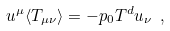Convert formula to latex. <formula><loc_0><loc_0><loc_500><loc_500>u ^ { \mu } \langle T _ { \mu \nu } \rangle = - p _ { 0 } T ^ { d } u _ { \nu } \ ,</formula> 